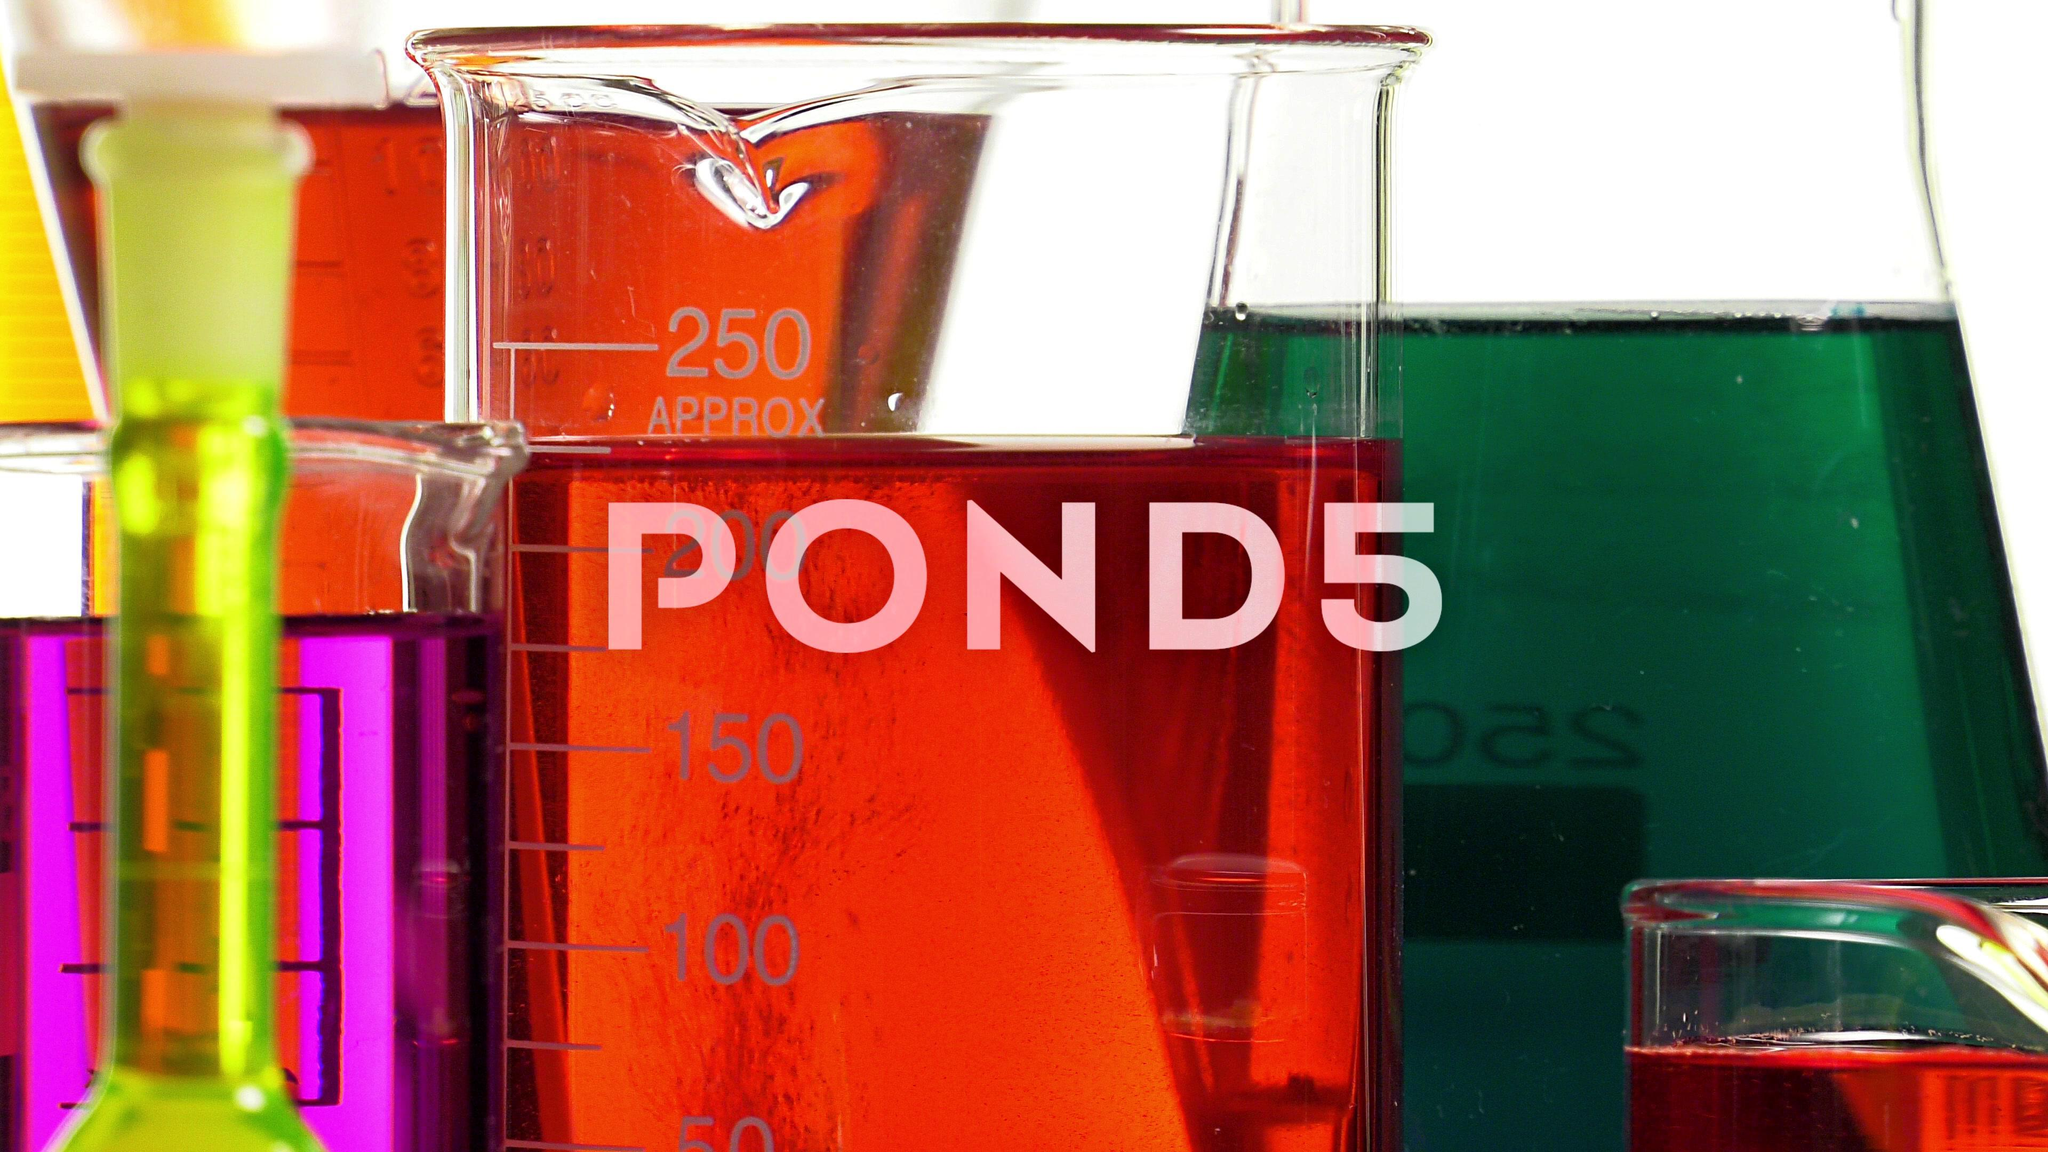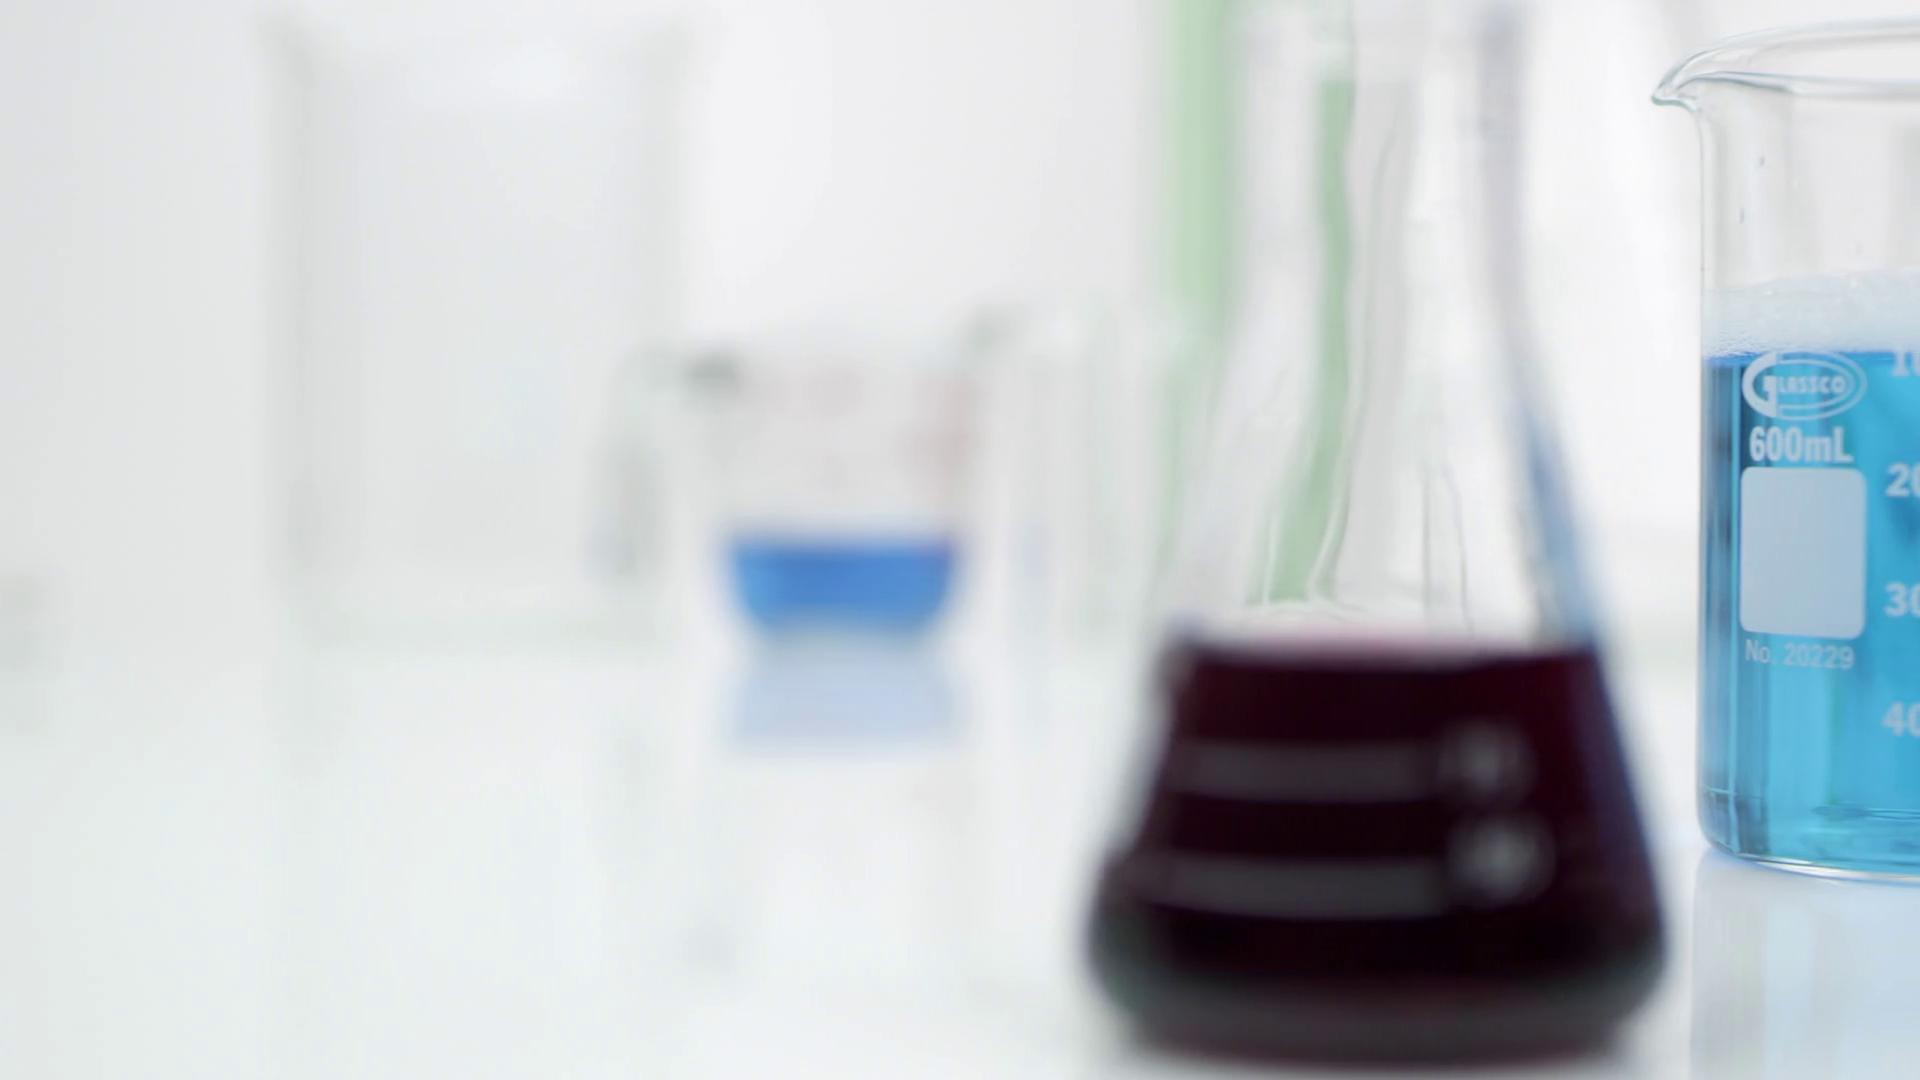The first image is the image on the left, the second image is the image on the right. For the images shown, is this caption "Three containers with brightly colored liquid sit together in the image on the left." true? Answer yes or no. No. 